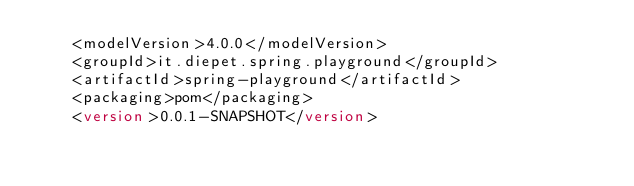Convert code to text. <code><loc_0><loc_0><loc_500><loc_500><_XML_>	<modelVersion>4.0.0</modelVersion>
	<groupId>it.diepet.spring.playground</groupId>
	<artifactId>spring-playground</artifactId>
	<packaging>pom</packaging>
	<version>0.0.1-SNAPSHOT</version></code> 